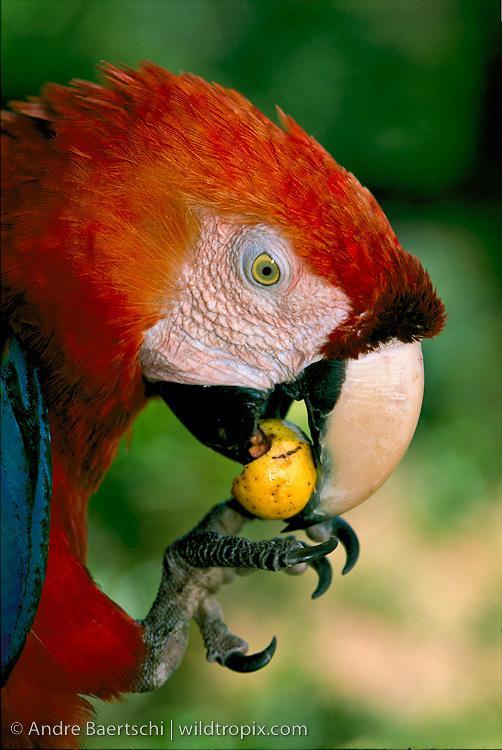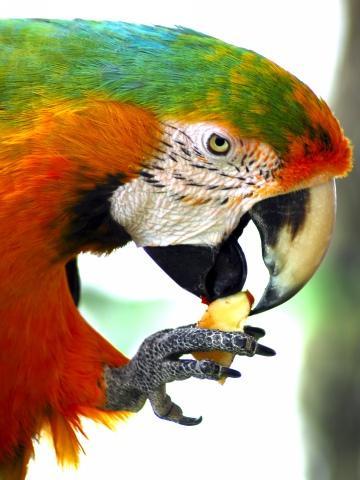The first image is the image on the left, the second image is the image on the right. Evaluate the accuracy of this statement regarding the images: "Each image shows a single parrot surrounded by leafy green foliage, and all parrots have heads angled leftward.". Is it true? Answer yes or no. No. The first image is the image on the left, the second image is the image on the right. Evaluate the accuracy of this statement regarding the images: "One macaw is not eating anything.". Is it true? Answer yes or no. No. 